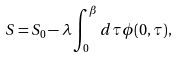Convert formula to latex. <formula><loc_0><loc_0><loc_500><loc_500>S = S _ { 0 } - \lambda \int _ { 0 } ^ { \beta } d \tau \phi ( 0 , \tau ) ,</formula> 